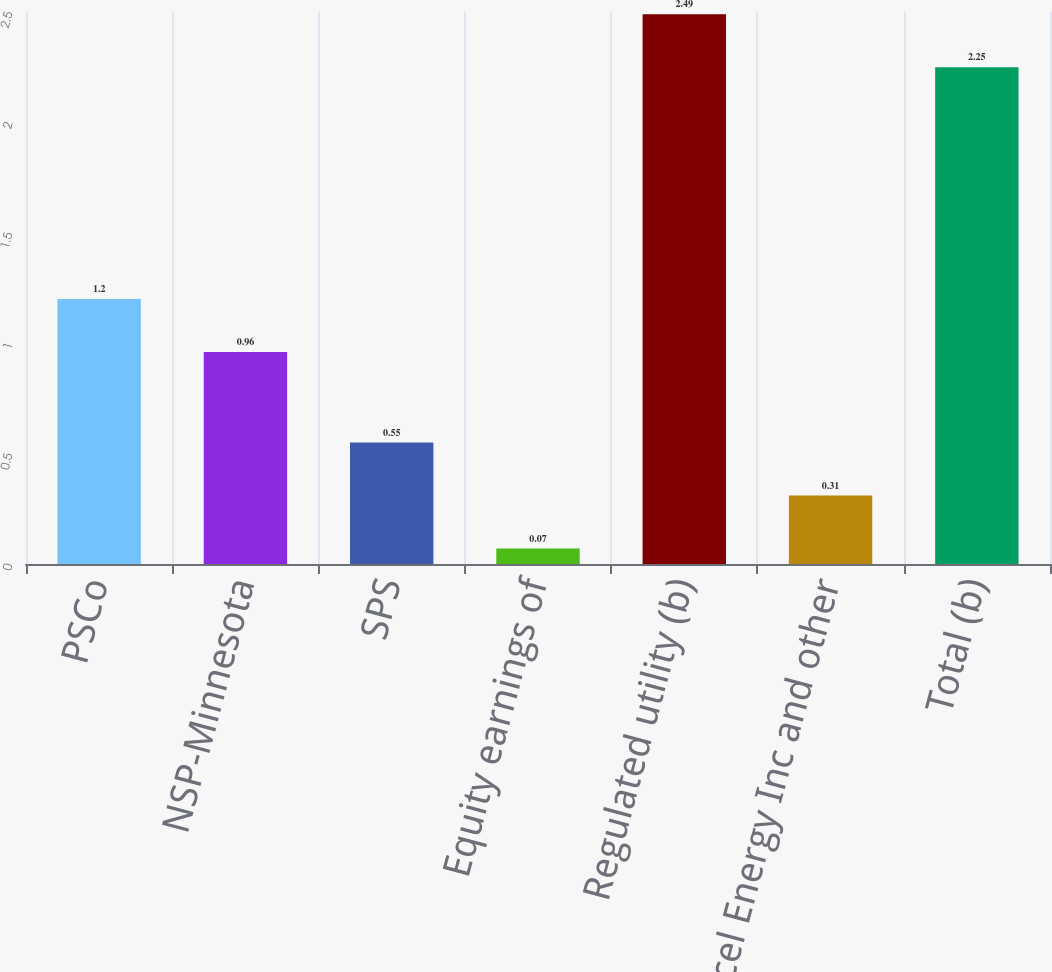Convert chart to OTSL. <chart><loc_0><loc_0><loc_500><loc_500><bar_chart><fcel>PSCo<fcel>NSP-Minnesota<fcel>SPS<fcel>Equity earnings of<fcel>Regulated utility (b)<fcel>Xcel Energy Inc and other<fcel>Total (b)<nl><fcel>1.2<fcel>0.96<fcel>0.55<fcel>0.07<fcel>2.49<fcel>0.31<fcel>2.25<nl></chart> 